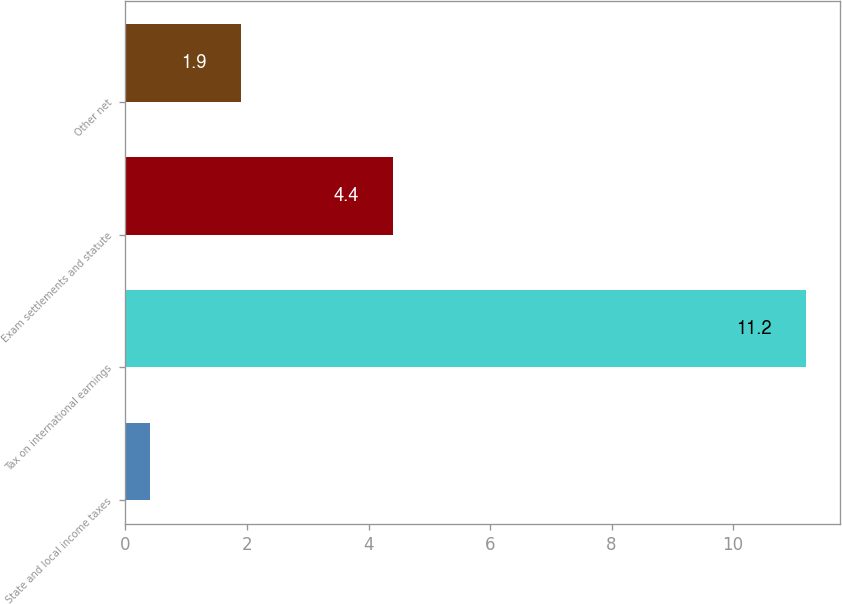<chart> <loc_0><loc_0><loc_500><loc_500><bar_chart><fcel>State and local income taxes<fcel>Tax on international earnings<fcel>Exam settlements and statute<fcel>Other net<nl><fcel>0.4<fcel>11.2<fcel>4.4<fcel>1.9<nl></chart> 